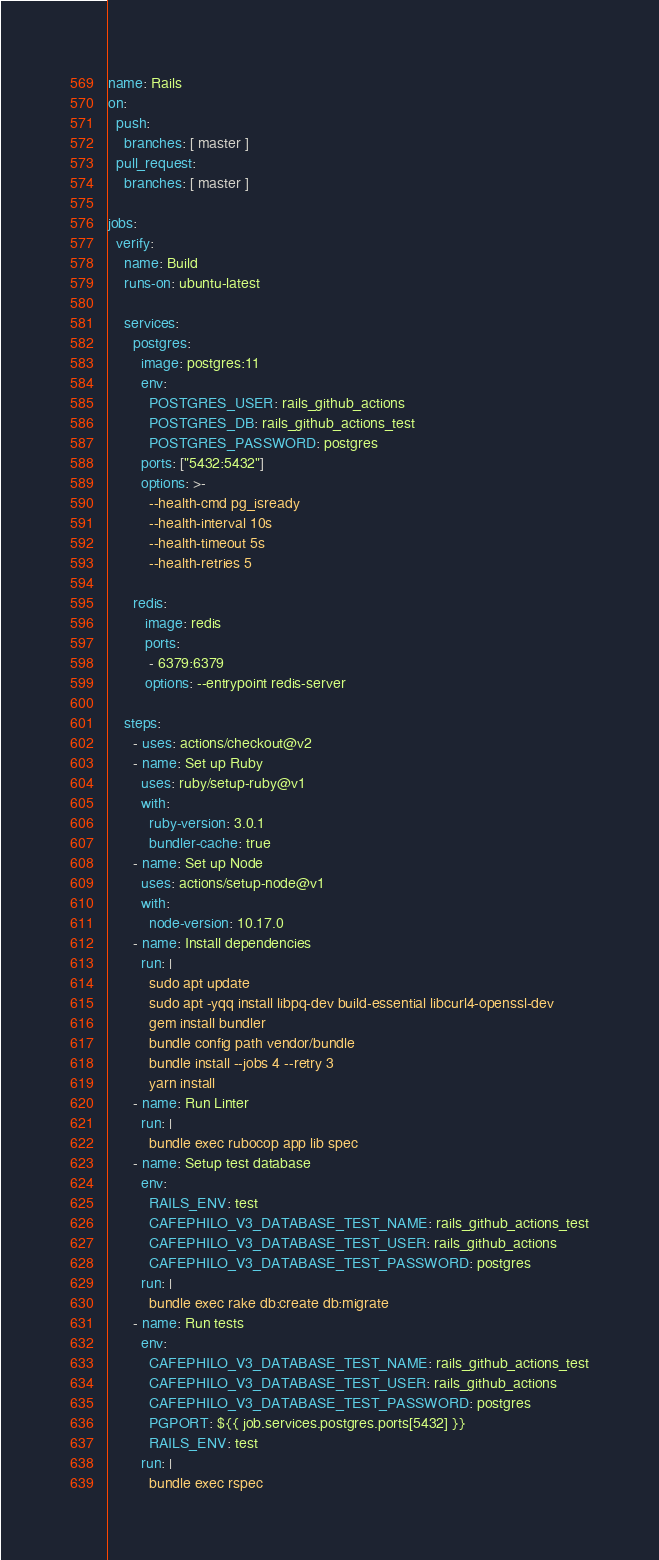<code> <loc_0><loc_0><loc_500><loc_500><_YAML_>name: Rails
on:
  push:
    branches: [ master ]
  pull_request:
    branches: [ master ]

jobs:
  verify:
    name: Build
    runs-on: ubuntu-latest

    services:
      postgres:
        image: postgres:11
        env:
          POSTGRES_USER: rails_github_actions
          POSTGRES_DB: rails_github_actions_test
          POSTGRES_PASSWORD: postgres
        ports: ["5432:5432"]
        options: >-
          --health-cmd pg_isready
          --health-interval 10s
          --health-timeout 5s
          --health-retries 5

      redis:
         image: redis
         ports:
          - 6379:6379
         options: --entrypoint redis-server

    steps:
      - uses: actions/checkout@v2
      - name: Set up Ruby
        uses: ruby/setup-ruby@v1
        with:
          ruby-version: 3.0.1
          bundler-cache: true
      - name: Set up Node
        uses: actions/setup-node@v1
        with:
          node-version: 10.17.0
      - name: Install dependencies
        run: |
          sudo apt update
          sudo apt -yqq install libpq-dev build-essential libcurl4-openssl-dev
          gem install bundler
          bundle config path vendor/bundle
          bundle install --jobs 4 --retry 3
          yarn install
      - name: Run Linter
        run: |
          bundle exec rubocop app lib spec
      - name: Setup test database
        env:
          RAILS_ENV: test
          CAFEPHILO_V3_DATABASE_TEST_NAME: rails_github_actions_test
          CAFEPHILO_V3_DATABASE_TEST_USER: rails_github_actions
          CAFEPHILO_V3_DATABASE_TEST_PASSWORD: postgres
        run: |
          bundle exec rake db:create db:migrate
      - name: Run tests
        env:
          CAFEPHILO_V3_DATABASE_TEST_NAME: rails_github_actions_test
          CAFEPHILO_V3_DATABASE_TEST_USER: rails_github_actions
          CAFEPHILO_V3_DATABASE_TEST_PASSWORD: postgres
          PGPORT: ${{ job.services.postgres.ports[5432] }}
          RAILS_ENV: test
        run: |
          bundle exec rspec
</code> 